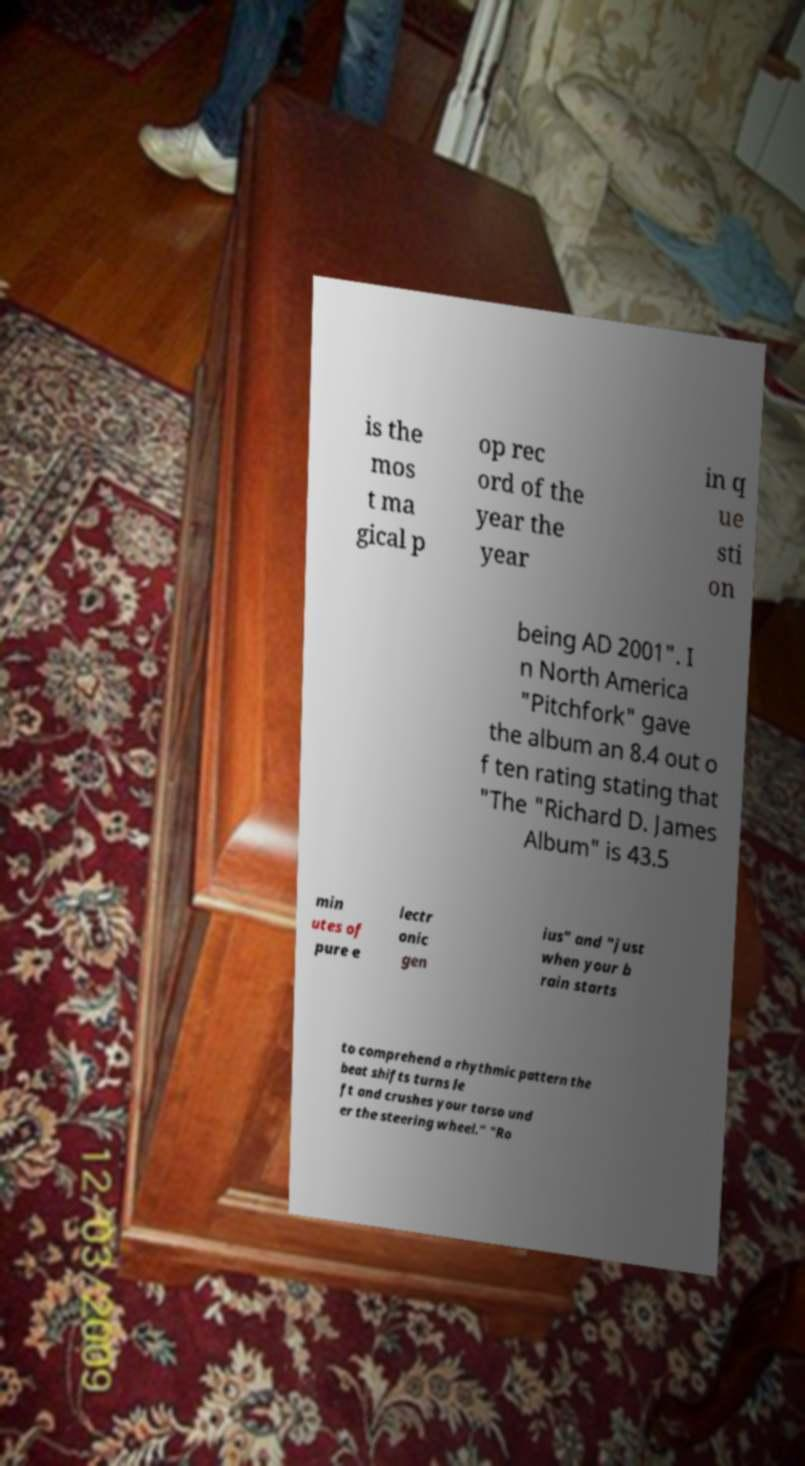Could you assist in decoding the text presented in this image and type it out clearly? is the mos t ma gical p op rec ord of the year the year in q ue sti on being AD 2001". I n North America "Pitchfork" gave the album an 8.4 out o f ten rating stating that "The "Richard D. James Album" is 43.5 min utes of pure e lectr onic gen ius" and "just when your b rain starts to comprehend a rhythmic pattern the beat shifts turns le ft and crushes your torso und er the steering wheel." "Ro 